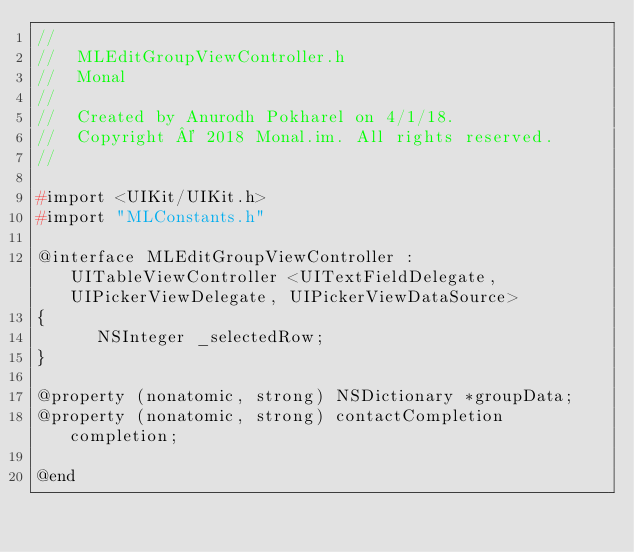<code> <loc_0><loc_0><loc_500><loc_500><_C_>//
//  MLEditGroupViewController.h
//  Monal
//
//  Created by Anurodh Pokharel on 4/1/18.
//  Copyright © 2018 Monal.im. All rights reserved.
//

#import <UIKit/UIKit.h>
#import "MLConstants.h"

@interface MLEditGroupViewController : UITableViewController <UITextFieldDelegate, UIPickerViewDelegate, UIPickerViewDataSource>
{
      NSInteger _selectedRow;
}

@property (nonatomic, strong) NSDictionary *groupData;
@property (nonatomic, strong) contactCompletion completion;

@end
</code> 